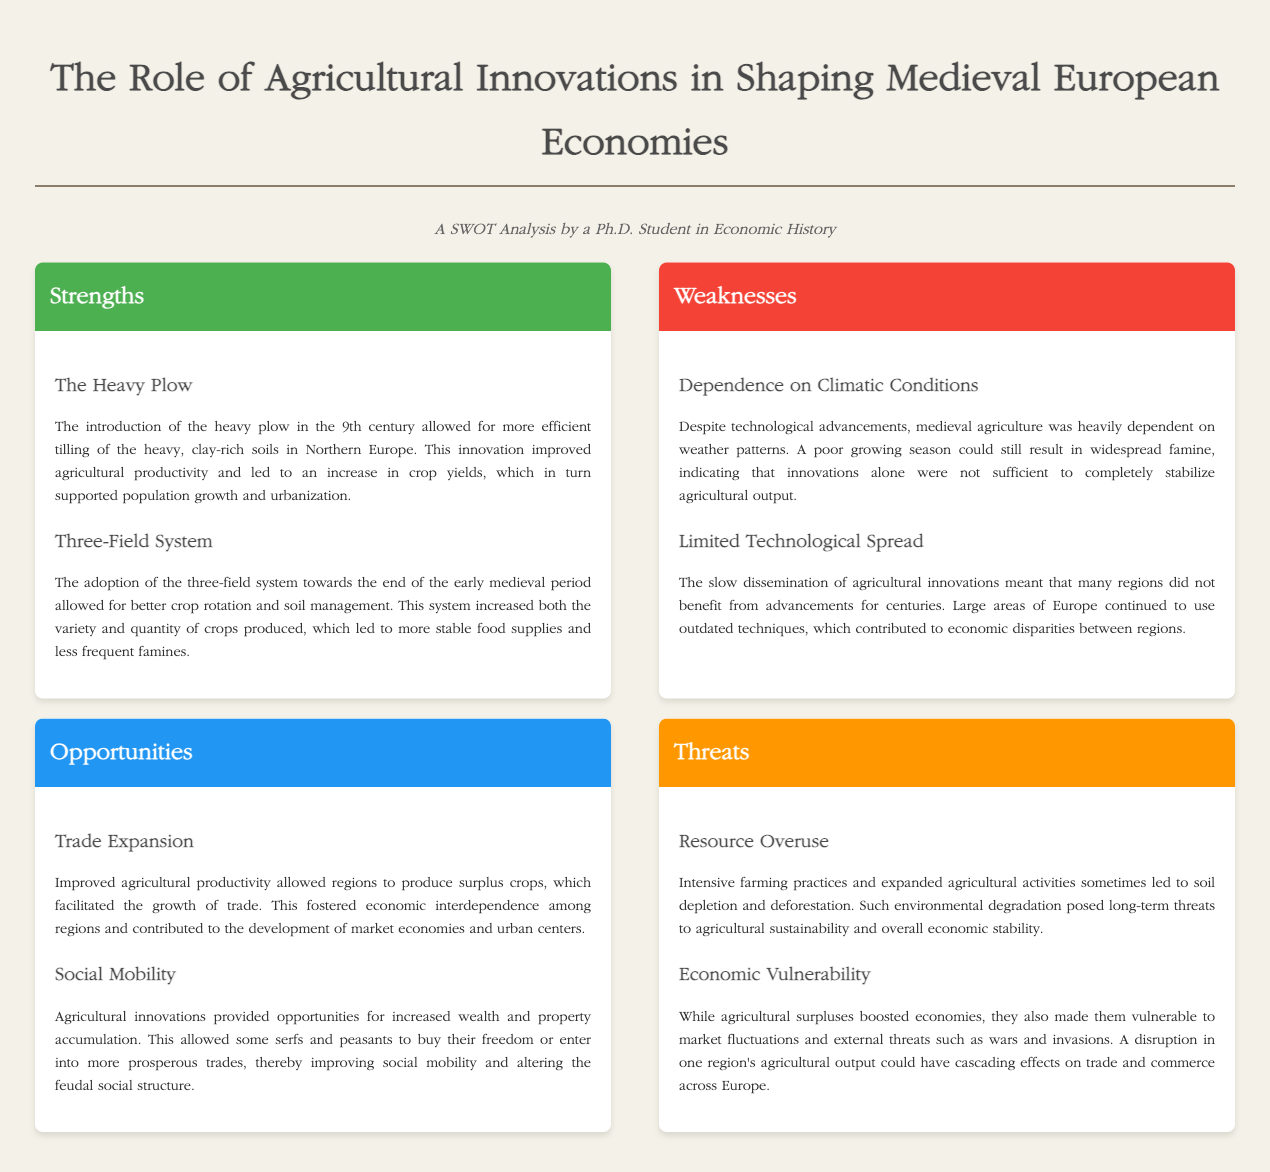What agricultural innovation improved crop yields in Northern Europe? The heavy plow introduced in the 9th century allowed for more efficient tilling of heavy, clay-rich soils, thereby improving agricultural productivity and crop yields.
Answer: The Heavy Plow What system allowed for better crop rotation during the medieval period? The three-field system allowed for better crop rotation and soil management, increasing both the variety and quantity of crops produced.
Answer: Three-Field System What was a major environmental threat posed by agricultural practices? Intensive farming practices led to soil depletion and deforestation, which posed long-term threats to sustainability.
Answer: Resource Overuse What social change did agricultural innovations encourage among serfs and peasants? Agricultural innovations provided opportunities for increased wealth accumulation, allowing some serfs and peasants to buy their freedom or enter prosperous trades, improving social mobility.
Answer: Social Mobility What factor heavily influenced medieval agricultural output despite advancements? Medieval agriculture was heavily dependent on weather patterns, indicating that innovations alone were not sufficient to completely stabilize agricultural output.
Answer: Dependence on Climatic Conditions What economic impact did improved agricultural productivity have on trade? Improved agricultural productivity allowed regions to produce surplus crops, facilitating the growth of trade and contributing to market economies.
Answer: Trade Expansion What was a consequence of limited technological spread across regions? The slow dissemination of agricultural innovations meant many regions did not benefit from advancements for centuries, contributing to economic disparities.
Answer: Limited Technological Spread What potential risk accompanied agricultural surpluses in medieval economies? Agricultural surpluses boosted economies but also made them vulnerable to market fluctuations and external threats such as wars and invasions.
Answer: Economic Vulnerability 